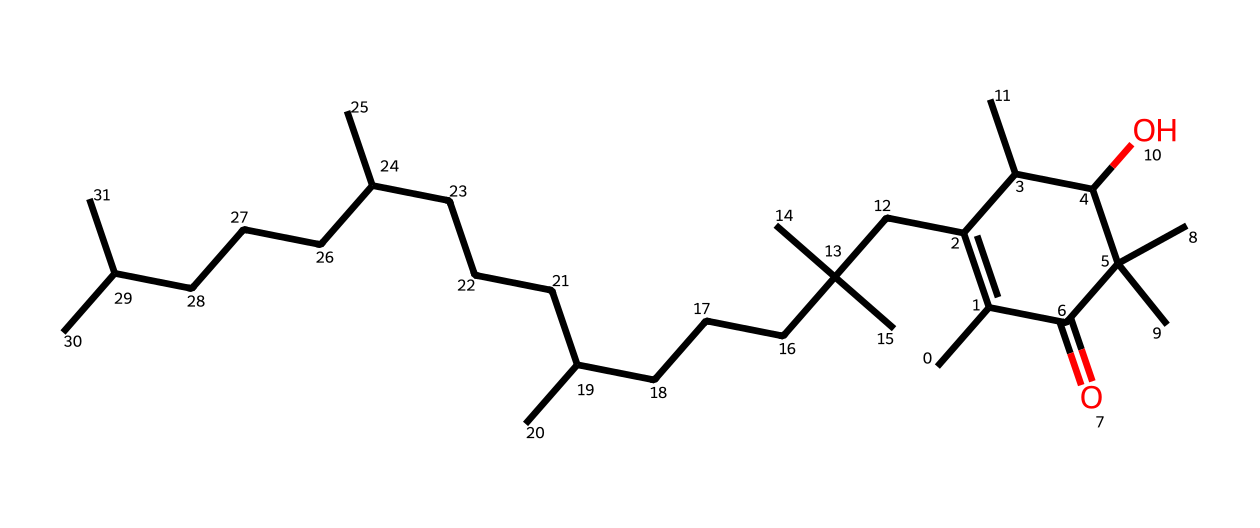What is the primary functional group present in this molecule? The primary functional group in this molecule is the hydroxyl group (-OH), which is evident from the presence of the -O atom connected to a carbon atom.
Answer: hydroxyl group How many carbon atoms are present in this vitamin E structure? Counting the carbon atoms in the provided SMILES representation, there are 29 carbon atoms.
Answer: 29 What is the role of vitamin E in protecting genetic material? Vitamin E functions as an antioxidant, helping to neutralize free radicals that can cause oxidative stress, thereby protecting genetic material.
Answer: antioxidant Which part of the chemical structure contributes to its hydrophobic nature? The long hydrocarbon chains (the multiple carbon chains seen in the structure) contribute to its hydrophobic nature, creating non-polar characteristics.
Answer: hydrocarbon chains Does this molecule contain any double bonds? Yes, there are double bonds present between carbon atoms, specifically in the ring structure, indicated by the '=' symbol in the SMILES.
Answer: yes In what form is this vitamin E structure primarily found in biological systems, tocopherol or tocotrienol? The provided structure is associated with tocopherol, which is the most common form of vitamin E found in biological systems.
Answer: tocopherol 